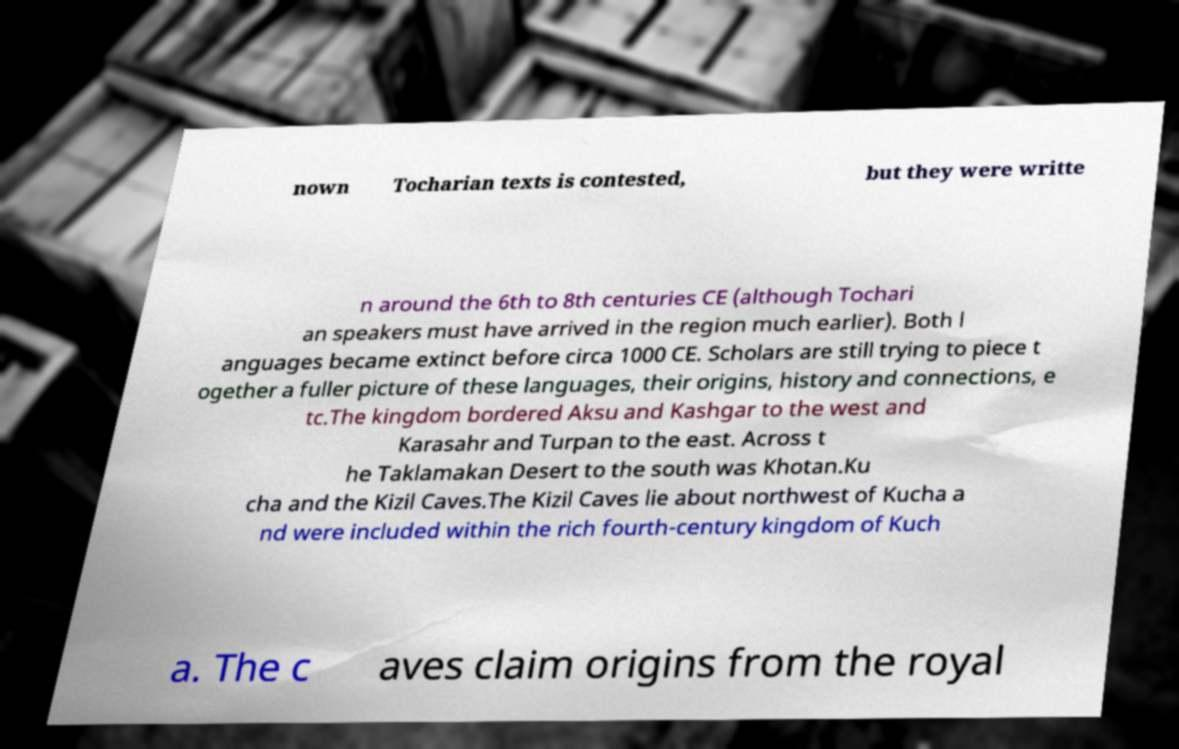Can you read and provide the text displayed in the image?This photo seems to have some interesting text. Can you extract and type it out for me? nown Tocharian texts is contested, but they were writte n around the 6th to 8th centuries CE (although Tochari an speakers must have arrived in the region much earlier). Both l anguages became extinct before circa 1000 CE. Scholars are still trying to piece t ogether a fuller picture of these languages, their origins, history and connections, e tc.The kingdom bordered Aksu and Kashgar to the west and Karasahr and Turpan to the east. Across t he Taklamakan Desert to the south was Khotan.Ku cha and the Kizil Caves.The Kizil Caves lie about northwest of Kucha a nd were included within the rich fourth-century kingdom of Kuch a. The c aves claim origins from the royal 